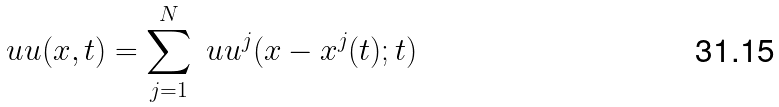<formula> <loc_0><loc_0><loc_500><loc_500>\ u u ( x , t ) = \sum _ { j = 1 } ^ { N } \ u u ^ { j } ( x - x ^ { j } ( t ) ; t )</formula> 